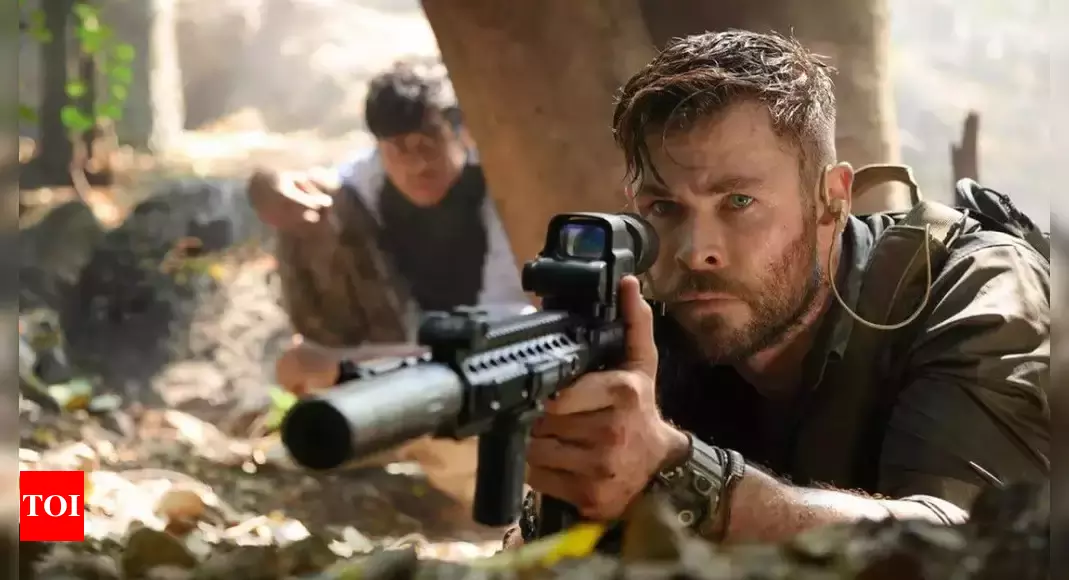In reality, what might be the challenges faced by someone in such a high-stakes tactical situation in a dense jungle environment? In reality, someone in a high-stakes tactical situation in a dense jungle environment would face numerous challenges. Navigating through thick foliage can hamper movement and visibility, making it difficult to maintain stealth and stay aware of surroundings. The humid and unpredictable weather conditions pose additional physical and technical challenges, potentially affecting equipment functionality. The presence of wildlife and the risk of diseases from insects and plants add to the environmental hazards. Communicating and coordinating with team members is also tough due to the potential for signal interference and the need for silent operations. Overall, such a setting demands exceptional physical endurance, mental acuity, and adaptability.  What motivates Tyler Rake's character in such a dangerous mission? Tyler Rake, the character portrayed by Chris Hemsworth, is motivated by a complex mix of professional duty, personal redemption, and a sense of responsibility towards those he aims to protect. Deeply impacted by past traumas and losses, Rake is driven to complete dangerous missions as a means of coping with his inner turmoil and as an effort to make amends for perceived failures. His unwavering determination and risk-taking tendencies highlight a profound commitment to his principles and a relentless pursuit of his goals, no matter the peril involved. This motivation adds depth to his character, making him both formidable and relatable. 